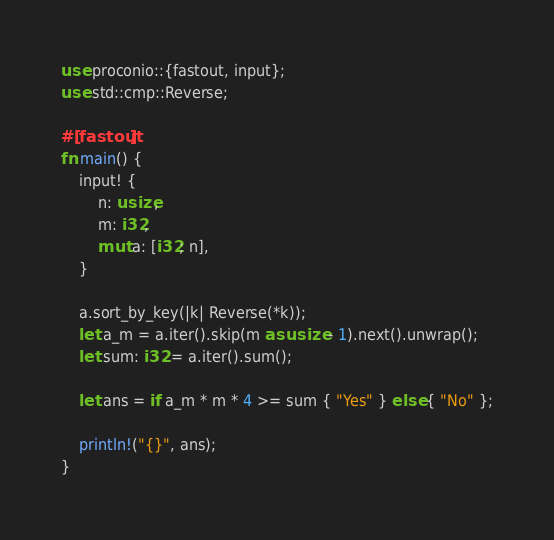Convert code to text. <code><loc_0><loc_0><loc_500><loc_500><_Rust_>use proconio::{fastout, input};
use std::cmp::Reverse;

#[fastout]
fn main() {
    input! {
        n: usize,
        m: i32,
        mut a: [i32; n],
    }

    a.sort_by_key(|k| Reverse(*k));
    let a_m = a.iter().skip(m as usize - 1).next().unwrap();
    let sum: i32 = a.iter().sum();

    let ans = if a_m * m * 4 >= sum { "Yes" } else { "No" };

    println!("{}", ans);
}
</code> 